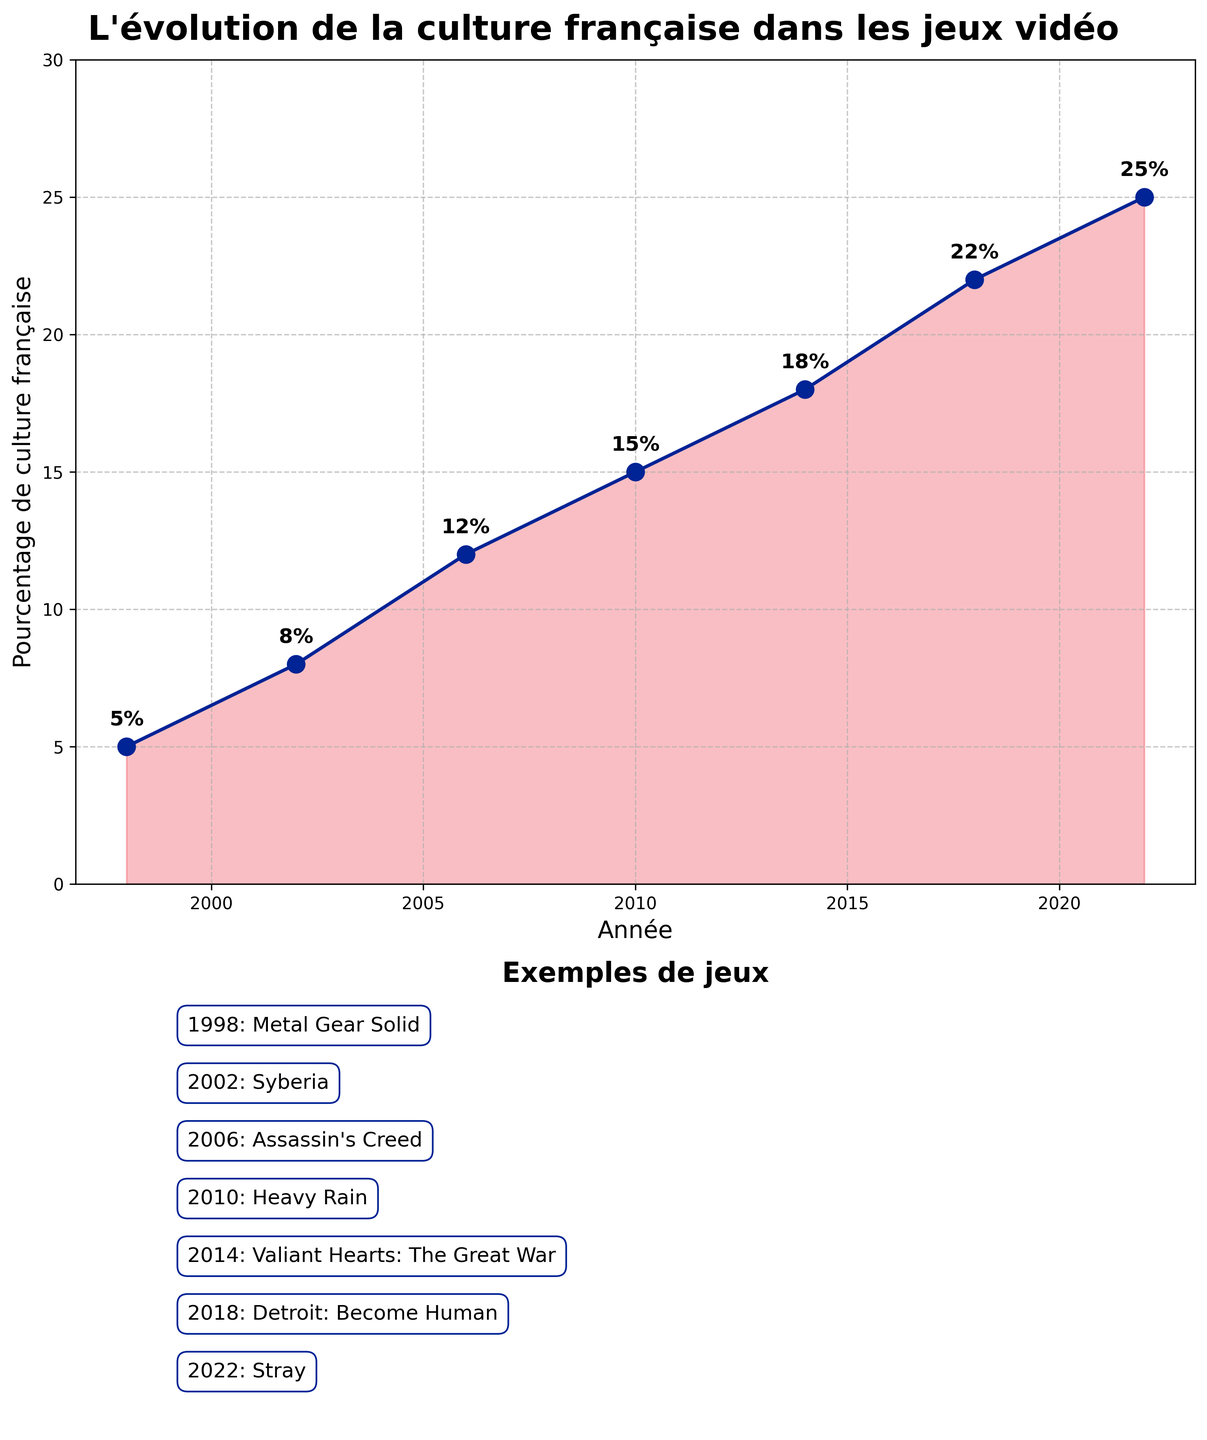What is the title of the figure? The title is the first thing you see at the top of the figure. It is usually in a larger and bolder font than the rest of the text.
Answer: L'évolution de la culture française dans les jeux vidéo Which year saw the highest percentage of French culture in globally successful video games? The highest percentage can be found by looking for the data point with the highest vertical position on the Y-axis.
Answer: 2022 What was the percentage of French cultural elements in video games in the year 2006? Locate the data point corresponding to the year 2006 on the X-axis and read the associated value on the Y-axis.
Answer: 12% Between which two consecutive years did the percentage of French cultural elements increase the most? Calculate the increase between consecutive years by subtracting the earlier year's percentage from the later year's percentage. Compare each of these increases to find the largest.
Answer: 2018 and 2022 What is the trend in the percentage of French cultural elements in video games from 1998 to 2022? Observe the line connecting the data points from 1998 to 2022. The trend can be identified as increasing, decreasing, or remaining constant based on the direction of the line.
Answer: Increasing What are the game examples mentioned in the subplot for the year 2014? To find the game example for a particular year, look at the second subplot, which lists the games along with their release years.
Answer: Valiant Hearts: The Great War How much did the percentage of French culture in video games increase from 2002 to 2010? Identify the percentages for 2002 and 2010. Subtract the percentage for 2002 from the percentage for 2010 to find the increase.
Answer: 7% Which year had a percentage of French cultural elements in video games that was equal to 18%? Locate the data point that corresponds to 18% on the Y-axis and trace it back to the associated year on the X-axis.
Answer: 2014 What was the average percentage of French cultural elements in video games for the years provided? Sum all the percentages given and divide by the number of data points (years). (5 + 8 + 12 + 15 + 18 + 22 + 25) / 7 = 15
Answer: 15% How does the second subplot complement the first subplot? The second subplot provides specific examples of games that were released in each year listed in the first subplot, giving context to the percentages shown.
Answer: It provides game context 